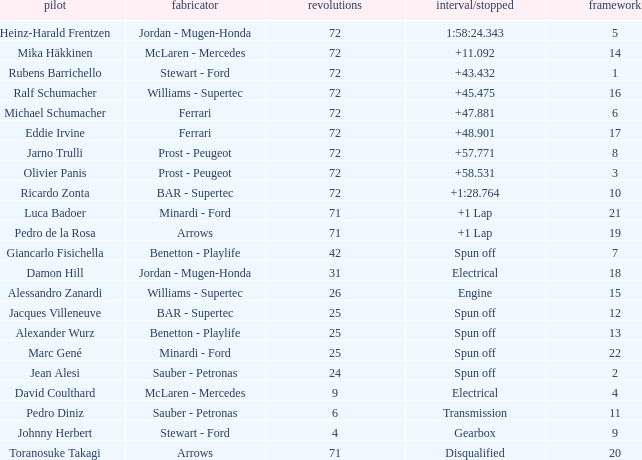How many laps did Ricardo Zonta drive with a grid less than 14? 72.0. 